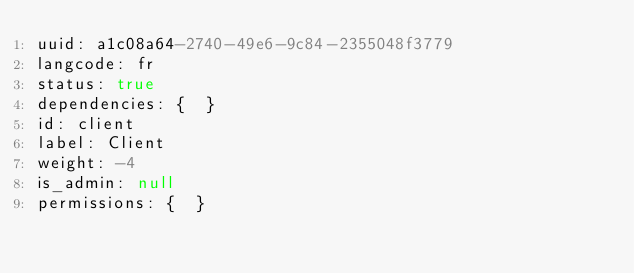Convert code to text. <code><loc_0><loc_0><loc_500><loc_500><_YAML_>uuid: a1c08a64-2740-49e6-9c84-2355048f3779
langcode: fr
status: true
dependencies: {  }
id: client
label: Client
weight: -4
is_admin: null
permissions: {  }
</code> 